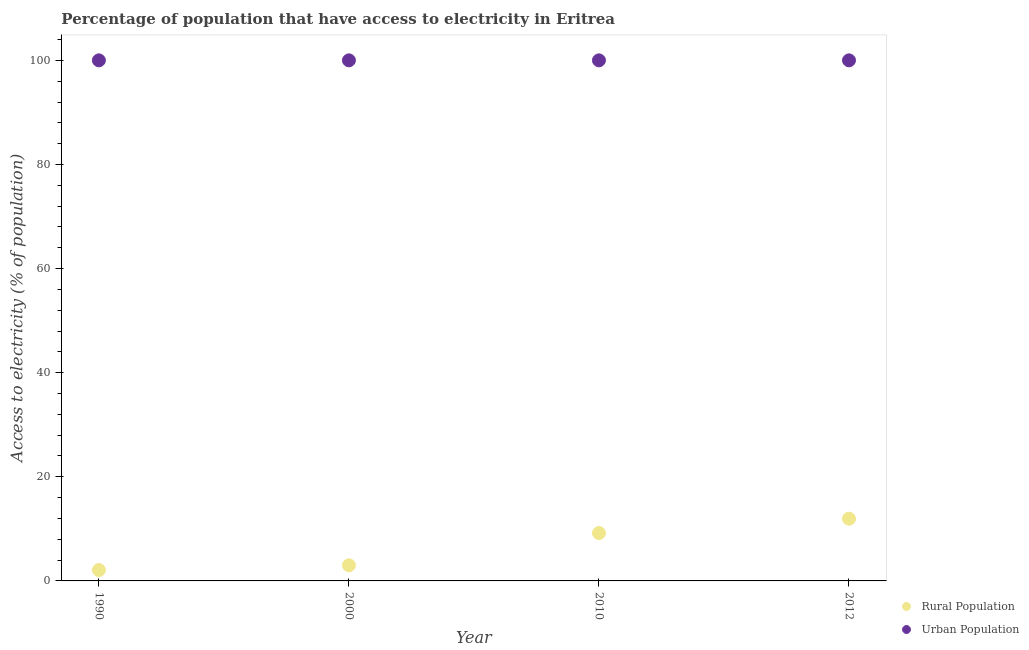How many different coloured dotlines are there?
Offer a very short reply. 2. What is the percentage of urban population having access to electricity in 2000?
Your answer should be compact. 100. Across all years, what is the maximum percentage of rural population having access to electricity?
Provide a short and direct response. 11.95. Across all years, what is the minimum percentage of rural population having access to electricity?
Provide a short and direct response. 2.1. What is the total percentage of rural population having access to electricity in the graph?
Provide a short and direct response. 26.25. What is the difference between the percentage of urban population having access to electricity in 2010 and the percentage of rural population having access to electricity in 2012?
Your answer should be compact. 88.05. What is the average percentage of rural population having access to electricity per year?
Give a very brief answer. 6.56. In the year 2012, what is the difference between the percentage of rural population having access to electricity and percentage of urban population having access to electricity?
Your answer should be very brief. -88.05. What is the ratio of the percentage of urban population having access to electricity in 2010 to that in 2012?
Make the answer very short. 1. What is the difference between the highest and the second highest percentage of rural population having access to electricity?
Offer a very short reply. 2.75. In how many years, is the percentage of urban population having access to electricity greater than the average percentage of urban population having access to electricity taken over all years?
Make the answer very short. 0. Is the sum of the percentage of rural population having access to electricity in 1990 and 2010 greater than the maximum percentage of urban population having access to electricity across all years?
Keep it short and to the point. No. Does the percentage of rural population having access to electricity monotonically increase over the years?
Keep it short and to the point. Yes. How many years are there in the graph?
Keep it short and to the point. 4. Are the values on the major ticks of Y-axis written in scientific E-notation?
Keep it short and to the point. No. What is the title of the graph?
Ensure brevity in your answer.  Percentage of population that have access to electricity in Eritrea. Does "Constant 2005 US$" appear as one of the legend labels in the graph?
Make the answer very short. No. What is the label or title of the X-axis?
Offer a very short reply. Year. What is the label or title of the Y-axis?
Your answer should be compact. Access to electricity (% of population). What is the Access to electricity (% of population) of Rural Population in 1990?
Keep it short and to the point. 2.1. What is the Access to electricity (% of population) of Urban Population in 2000?
Provide a succinct answer. 100. What is the Access to electricity (% of population) in Rural Population in 2010?
Your answer should be compact. 9.2. What is the Access to electricity (% of population) of Urban Population in 2010?
Provide a succinct answer. 100. What is the Access to electricity (% of population) of Rural Population in 2012?
Offer a terse response. 11.95. Across all years, what is the maximum Access to electricity (% of population) in Rural Population?
Your response must be concise. 11.95. What is the total Access to electricity (% of population) in Rural Population in the graph?
Ensure brevity in your answer.  26.25. What is the total Access to electricity (% of population) in Urban Population in the graph?
Offer a terse response. 400. What is the difference between the Access to electricity (% of population) of Urban Population in 1990 and that in 2010?
Your answer should be compact. 0. What is the difference between the Access to electricity (% of population) in Rural Population in 1990 and that in 2012?
Give a very brief answer. -9.85. What is the difference between the Access to electricity (% of population) of Urban Population in 1990 and that in 2012?
Your answer should be compact. 0. What is the difference between the Access to electricity (% of population) in Rural Population in 2000 and that in 2012?
Make the answer very short. -8.95. What is the difference between the Access to electricity (% of population) of Urban Population in 2000 and that in 2012?
Ensure brevity in your answer.  0. What is the difference between the Access to electricity (% of population) of Rural Population in 2010 and that in 2012?
Make the answer very short. -2.75. What is the difference between the Access to electricity (% of population) of Urban Population in 2010 and that in 2012?
Give a very brief answer. 0. What is the difference between the Access to electricity (% of population) in Rural Population in 1990 and the Access to electricity (% of population) in Urban Population in 2000?
Make the answer very short. -97.9. What is the difference between the Access to electricity (% of population) of Rural Population in 1990 and the Access to electricity (% of population) of Urban Population in 2010?
Your answer should be very brief. -97.9. What is the difference between the Access to electricity (% of population) of Rural Population in 1990 and the Access to electricity (% of population) of Urban Population in 2012?
Provide a short and direct response. -97.9. What is the difference between the Access to electricity (% of population) of Rural Population in 2000 and the Access to electricity (% of population) of Urban Population in 2010?
Provide a succinct answer. -97. What is the difference between the Access to electricity (% of population) of Rural Population in 2000 and the Access to electricity (% of population) of Urban Population in 2012?
Offer a terse response. -97. What is the difference between the Access to electricity (% of population) of Rural Population in 2010 and the Access to electricity (% of population) of Urban Population in 2012?
Ensure brevity in your answer.  -90.8. What is the average Access to electricity (% of population) in Rural Population per year?
Make the answer very short. 6.56. What is the average Access to electricity (% of population) in Urban Population per year?
Your answer should be very brief. 100. In the year 1990, what is the difference between the Access to electricity (% of population) of Rural Population and Access to electricity (% of population) of Urban Population?
Offer a terse response. -97.9. In the year 2000, what is the difference between the Access to electricity (% of population) of Rural Population and Access to electricity (% of population) of Urban Population?
Your answer should be compact. -97. In the year 2010, what is the difference between the Access to electricity (% of population) in Rural Population and Access to electricity (% of population) in Urban Population?
Your response must be concise. -90.8. In the year 2012, what is the difference between the Access to electricity (% of population) of Rural Population and Access to electricity (% of population) of Urban Population?
Keep it short and to the point. -88.05. What is the ratio of the Access to electricity (% of population) of Rural Population in 1990 to that in 2000?
Give a very brief answer. 0.7. What is the ratio of the Access to electricity (% of population) in Rural Population in 1990 to that in 2010?
Ensure brevity in your answer.  0.23. What is the ratio of the Access to electricity (% of population) of Rural Population in 1990 to that in 2012?
Your answer should be very brief. 0.18. What is the ratio of the Access to electricity (% of population) of Urban Population in 1990 to that in 2012?
Provide a succinct answer. 1. What is the ratio of the Access to electricity (% of population) in Rural Population in 2000 to that in 2010?
Your answer should be compact. 0.33. What is the ratio of the Access to electricity (% of population) of Rural Population in 2000 to that in 2012?
Provide a succinct answer. 0.25. What is the ratio of the Access to electricity (% of population) in Urban Population in 2000 to that in 2012?
Your response must be concise. 1. What is the ratio of the Access to electricity (% of population) of Rural Population in 2010 to that in 2012?
Offer a terse response. 0.77. What is the ratio of the Access to electricity (% of population) in Urban Population in 2010 to that in 2012?
Offer a terse response. 1. What is the difference between the highest and the second highest Access to electricity (% of population) of Rural Population?
Provide a succinct answer. 2.75. What is the difference between the highest and the second highest Access to electricity (% of population) of Urban Population?
Keep it short and to the point. 0. What is the difference between the highest and the lowest Access to electricity (% of population) in Rural Population?
Provide a short and direct response. 9.85. 